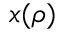<formula> <loc_0><loc_0><loc_500><loc_500>x ( \rho )</formula> 